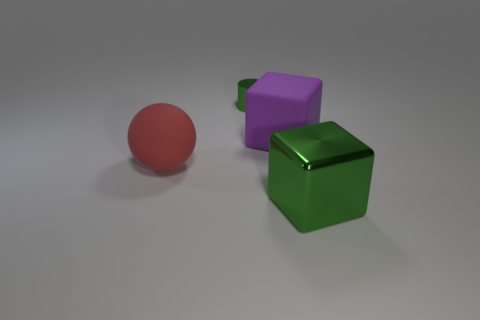What shape is the big metal thing that is the same color as the small metal cylinder?
Provide a succinct answer. Cube. There is a large thing that is the same color as the tiny thing; what is its material?
Offer a very short reply. Metal. There is a matte object that is right of the green metallic cylinder; is it the same size as the big red thing?
Offer a terse response. Yes. Do the large matte object that is to the right of the tiny metal cylinder and the red matte thing have the same shape?
Your answer should be compact. No. What number of things are either tiny cylinders or green shiny things behind the big rubber sphere?
Your response must be concise. 1. Are there fewer small gray matte blocks than cylinders?
Make the answer very short. Yes. Is the number of tiny brown rubber things greater than the number of balls?
Provide a short and direct response. No. What number of tiny green cylinders are behind the thing on the right side of the large matte object on the right side of the tiny green shiny cylinder?
Your response must be concise. 1. How many metallic objects are red balls or small cylinders?
Offer a very short reply. 1. How big is the cube left of the green shiny object in front of the big red rubber thing?
Make the answer very short. Large. 